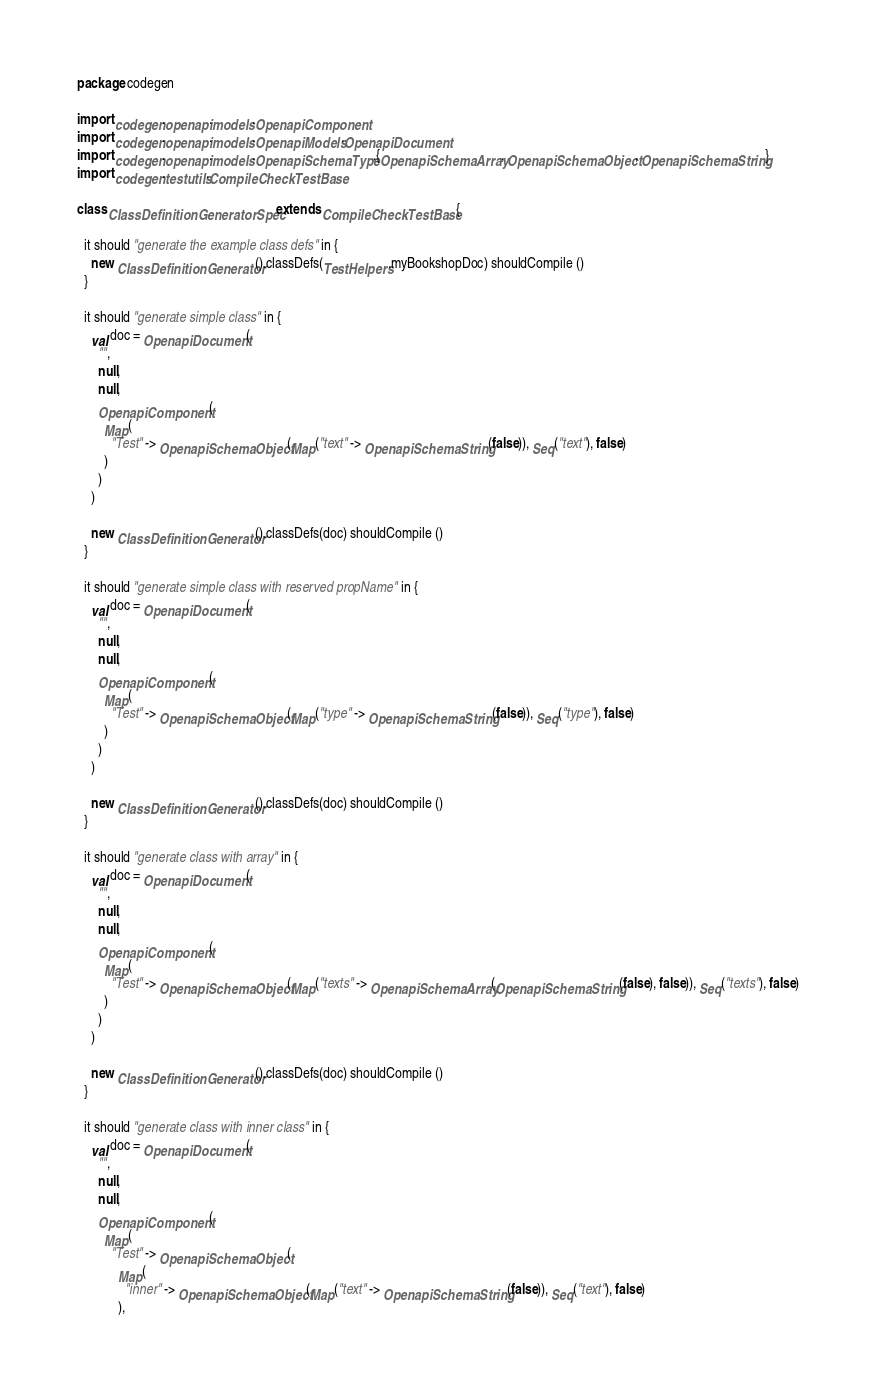<code> <loc_0><loc_0><loc_500><loc_500><_Scala_>package codegen

import codegen.openapi.models.OpenapiComponent
import codegen.openapi.models.OpenapiModels.OpenapiDocument
import codegen.openapi.models.OpenapiSchemaType.{OpenapiSchemaArray, OpenapiSchemaObject, OpenapiSchemaString}
import codegen.testutils.CompileCheckTestBase

class ClassDefinitionGeneratorSpec extends CompileCheckTestBase {

  it should "generate the example class defs" in {
    new ClassDefinitionGenerator().classDefs(TestHelpers.myBookshopDoc) shouldCompile ()
  }

  it should "generate simple class" in {
    val doc = OpenapiDocument(
      "",
      null,
      null,
      OpenapiComponent(
        Map(
          "Test" -> OpenapiSchemaObject(Map("text" -> OpenapiSchemaString(false)), Seq("text"), false)
        )
      )
    )

    new ClassDefinitionGenerator().classDefs(doc) shouldCompile ()
  }

  it should "generate simple class with reserved propName" in {
    val doc = OpenapiDocument(
      "",
      null,
      null,
      OpenapiComponent(
        Map(
          "Test" -> OpenapiSchemaObject(Map("type" -> OpenapiSchemaString(false)), Seq("type"), false)
        )
      )
    )

    new ClassDefinitionGenerator().classDefs(doc) shouldCompile ()
  }

  it should "generate class with array" in {
    val doc = OpenapiDocument(
      "",
      null,
      null,
      OpenapiComponent(
        Map(
          "Test" -> OpenapiSchemaObject(Map("texts" -> OpenapiSchemaArray(OpenapiSchemaString(false), false)), Seq("texts"), false)
        )
      )
    )

    new ClassDefinitionGenerator().classDefs(doc) shouldCompile ()
  }

  it should "generate class with inner class" in {
    val doc = OpenapiDocument(
      "",
      null,
      null,
      OpenapiComponent(
        Map(
          "Test" -> OpenapiSchemaObject(
            Map(
              "inner" -> OpenapiSchemaObject(Map("text" -> OpenapiSchemaString(false)), Seq("text"), false)
            ),</code> 